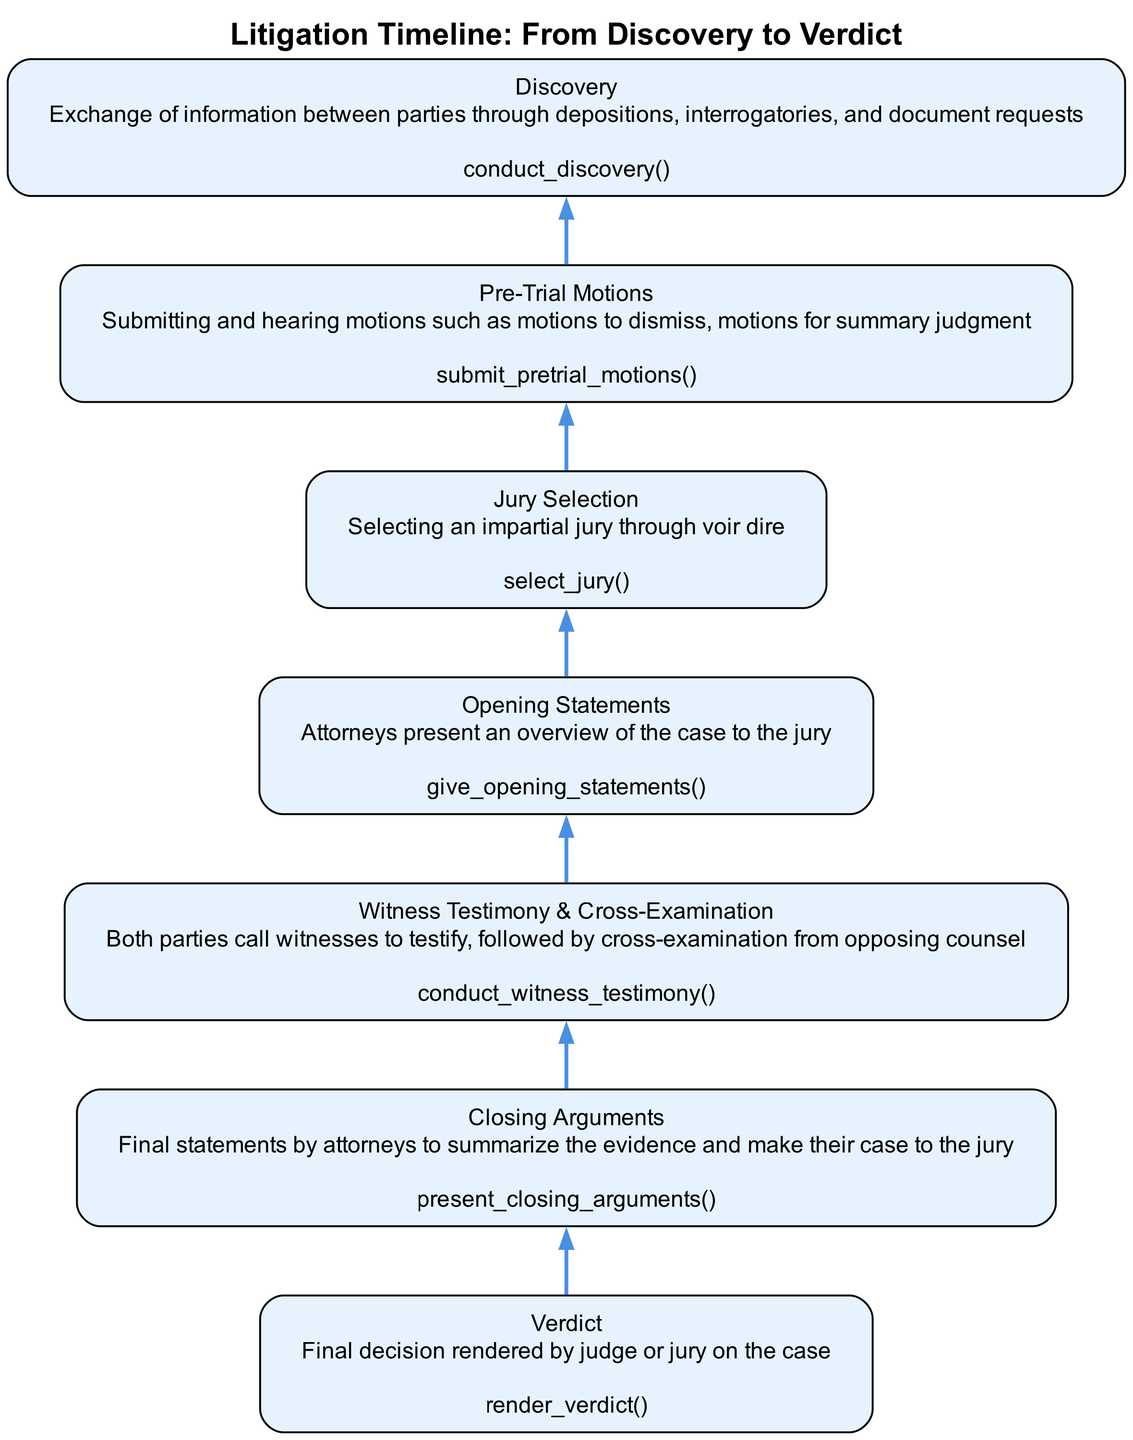What is the final stage of the litigation timeline? The diagram’s last node represents the final stage, which is "Verdict." This is visually indicated as the top-most node, signifying the concluding point in the timeline.
Answer: Verdict How many stages are in the litigation timeline? Counting the nodes in the diagram, there are a total of seven stages listed, each representing a different part of the litigation process.
Answer: Seven Which function is called during the "Witness Testimony & Cross-Examination" stage? Under the node labeled "Witness Testimony & Cross-Examination," the function associated is "conduct_witness_testimony," which is specified in the node details.
Answer: conduct_witness_testimony What precedes the "Closing Arguments" stage in the diagram? By analyzing the flow from bottom to top, "Witness Testimony & Cross-Examination" directly links to "Closing Arguments," denoting that it occurs just before this stage.
Answer: Witness Testimony & Cross-Examination Which stage involves selecting an impartial jury? The diagram specifies "Jury Selection" as the stage concerned with selecting an unbiased jury through the process of voir dire, making it clear in the flowchart.
Answer: Jury Selection What action is taken before the "Discovery" stage? Referring to the bottom of the diagram, "Pre-Trial Motions" is the stage that occurs directly before "Discovery," indicating that motions are submitted and heard prior to the exchange of information.
Answer: Pre-Trial Motions Which two stages are crucial for attorneys to present their cases? The stages "Opening Statements" and "Closing Arguments" are visually highlighted in the flowchart as primary moments when attorneys share their case with the jury at the beginning and conclusion of the trial.
Answer: Opening Statements and Closing Arguments 